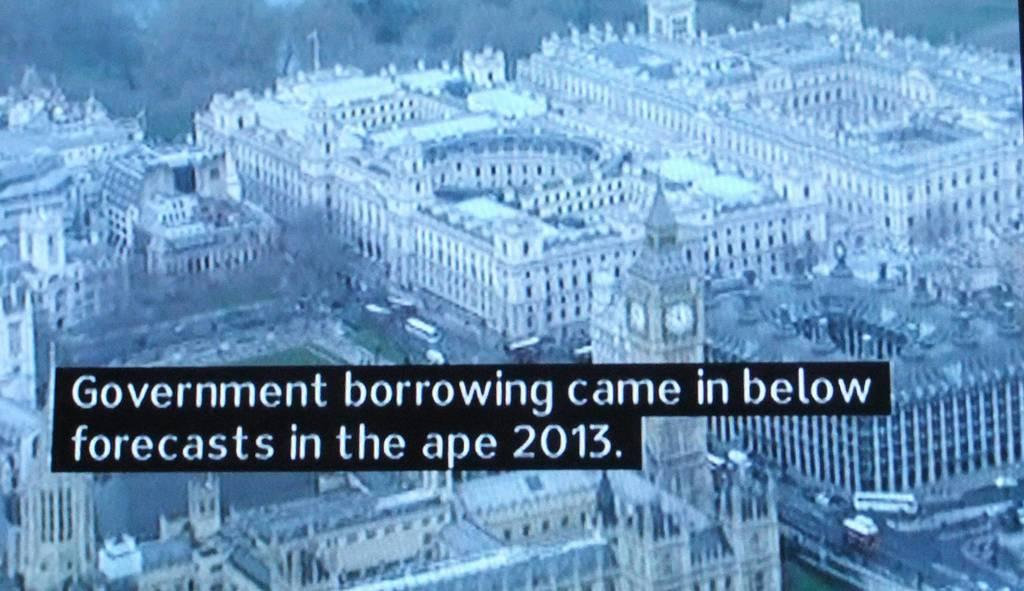What is the main subject of the poster in the image? The poster has multiple buildings depicted on it. What else can be seen on the poster besides the buildings? There is text on the poster with highlighted sections. What type of notebook is being used to make an argument in the image? There is no notebook or argument present in the image; it only features a poster with buildings and text. 